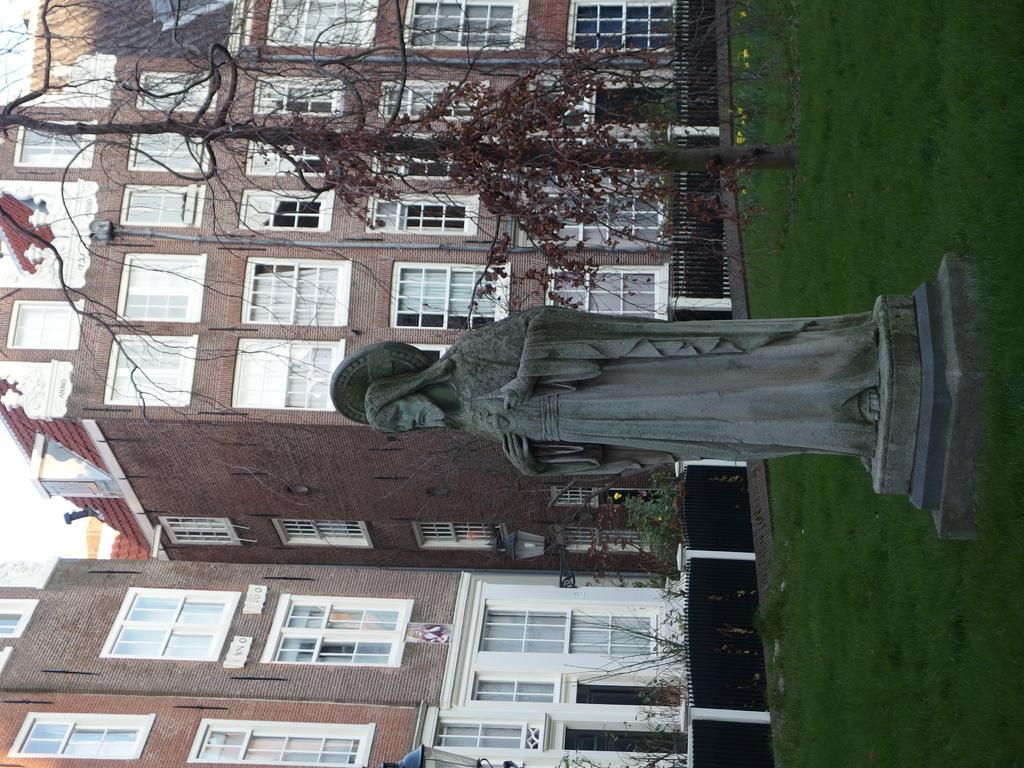What is the main subject in the image? There is a statue in the image. Where is the statue located? The statue is on a grass path. What can be seen behind the statue? There is a fence behind the statue, and a tree behind the fence. What other features can be seen in the background? There are poles with lights and buildings in the background. What type of muscle is being exercised by the statue in the image? The statue is not a living being and therefore does not have muscles. The statue is a stationary object in the image. 